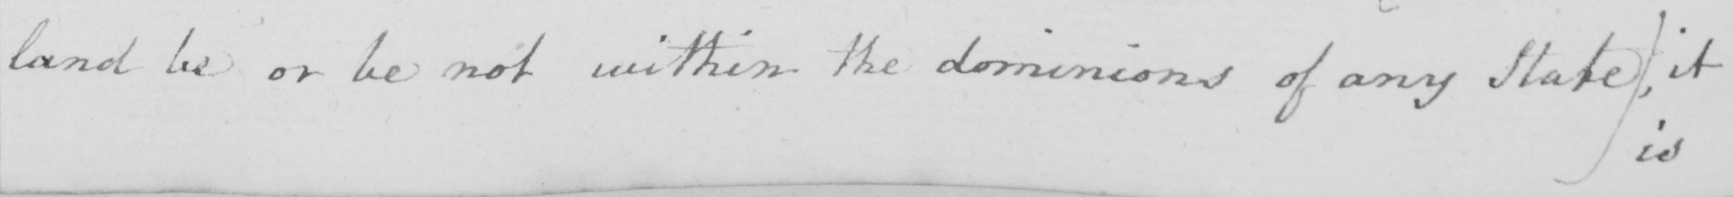Can you read and transcribe this handwriting? land be or be not within the dominions of any State )  , it 